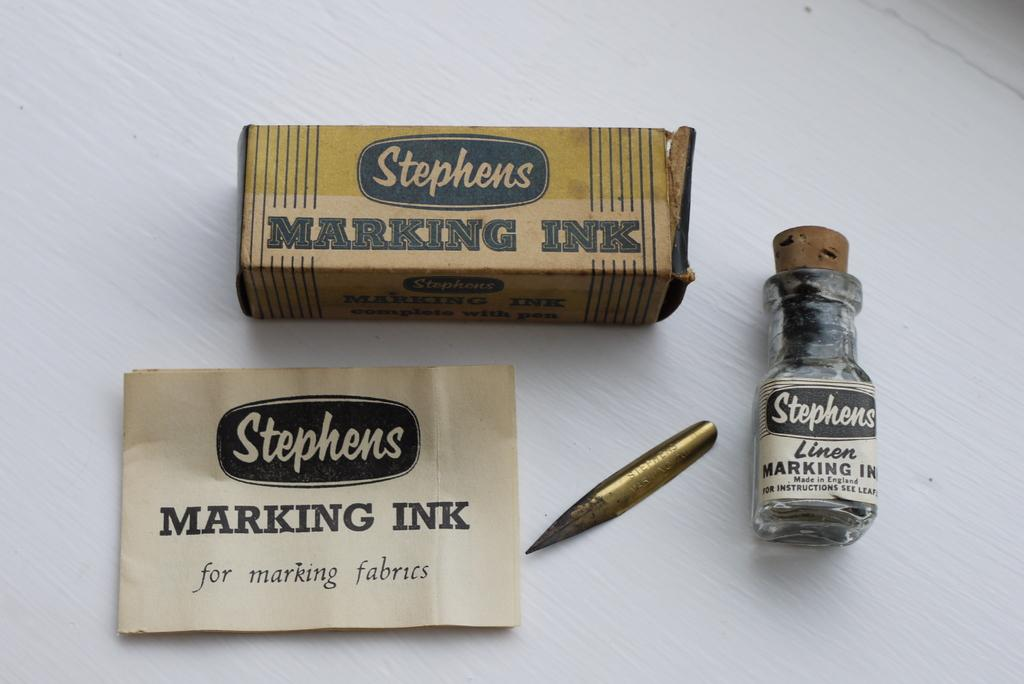What is the primary object in the image? There is a paper in the image. What tool is present for writing or drawing? There is a pencil in the image. What type of container is visible in the image? There is a bottle in the image. What type of packaging is present in the image? There is a cardboard box with some letters in the image. What color is the cushion in the image? There is no cushion present in the image. How many balls are visible in the image? There are no balls present in the image. 